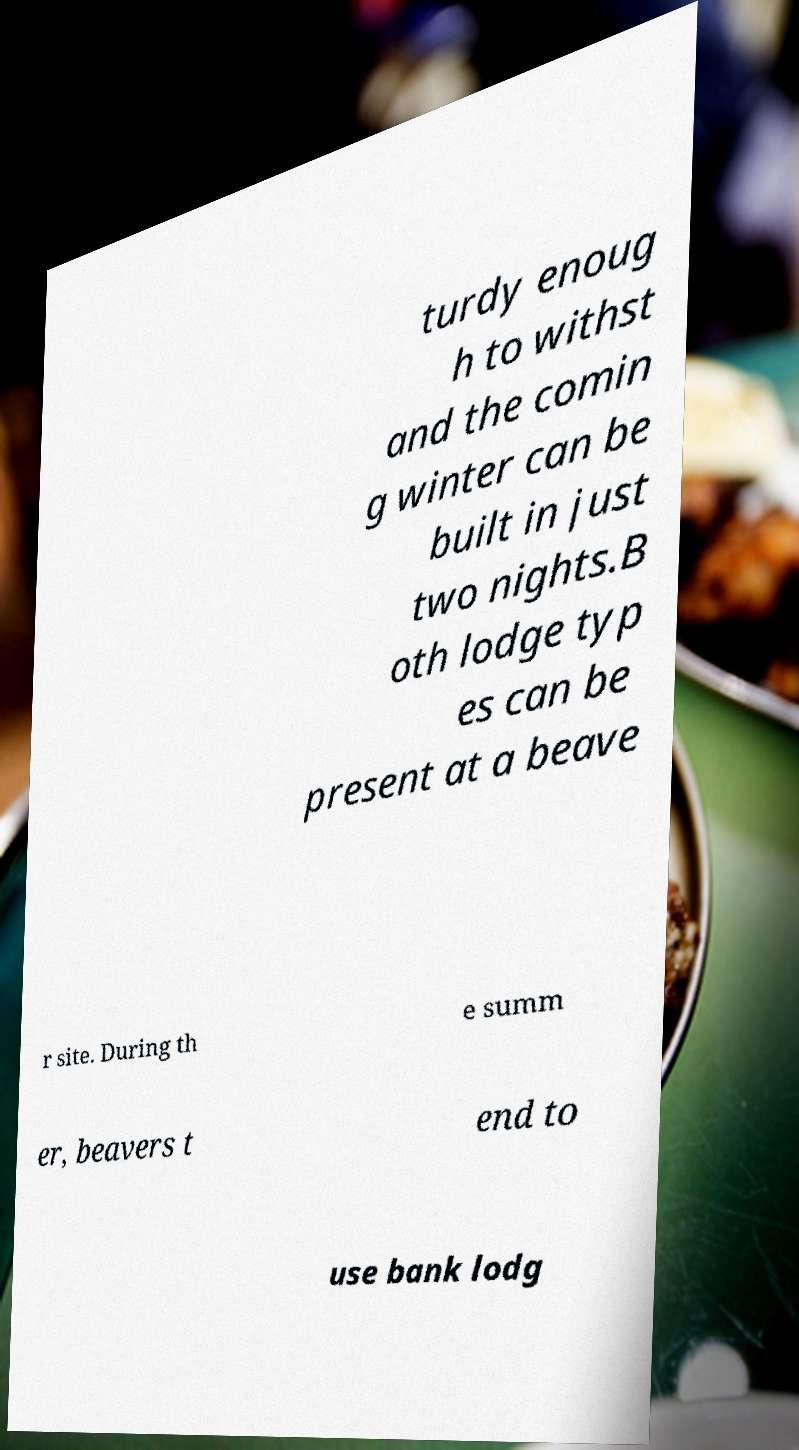Can you accurately transcribe the text from the provided image for me? turdy enoug h to withst and the comin g winter can be built in just two nights.B oth lodge typ es can be present at a beave r site. During th e summ er, beavers t end to use bank lodg 